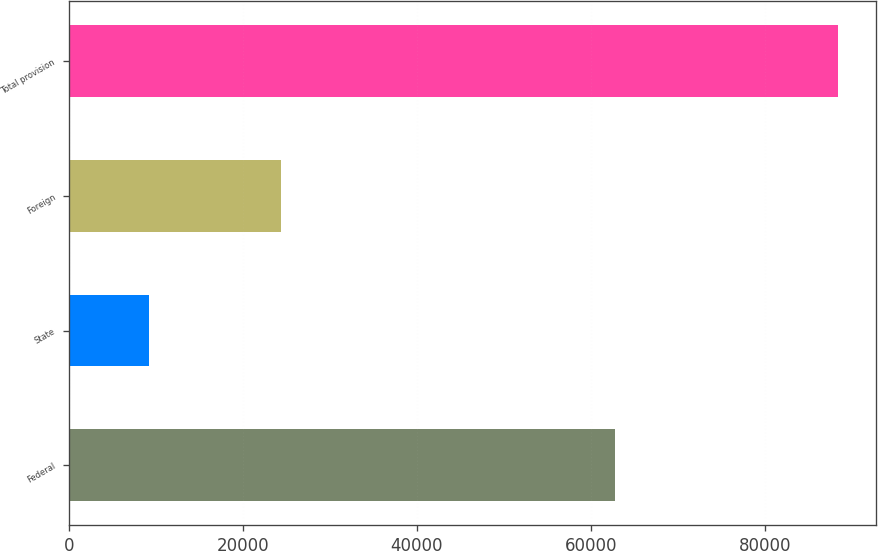Convert chart to OTSL. <chart><loc_0><loc_0><loc_500><loc_500><bar_chart><fcel>Federal<fcel>State<fcel>Foreign<fcel>Total provision<nl><fcel>62858<fcel>9262<fcel>24452<fcel>88427<nl></chart> 